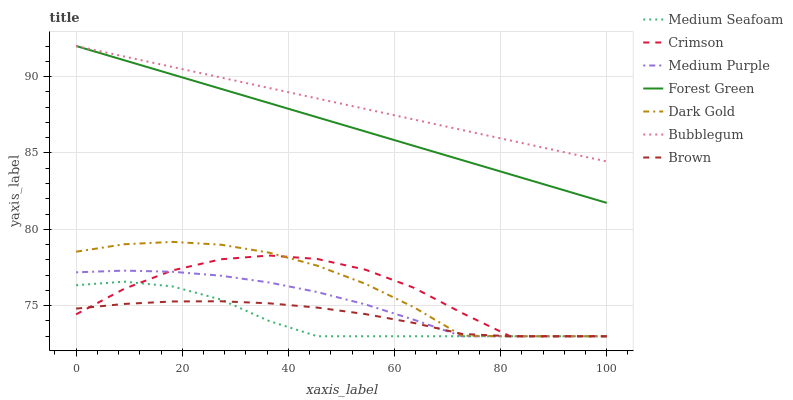Does Medium Seafoam have the minimum area under the curve?
Answer yes or no. Yes. Does Bubblegum have the maximum area under the curve?
Answer yes or no. Yes. Does Dark Gold have the minimum area under the curve?
Answer yes or no. No. Does Dark Gold have the maximum area under the curve?
Answer yes or no. No. Is Forest Green the smoothest?
Answer yes or no. Yes. Is Crimson the roughest?
Answer yes or no. Yes. Is Dark Gold the smoothest?
Answer yes or no. No. Is Dark Gold the roughest?
Answer yes or no. No. Does Brown have the lowest value?
Answer yes or no. Yes. Does Bubblegum have the lowest value?
Answer yes or no. No. Does Forest Green have the highest value?
Answer yes or no. Yes. Does Dark Gold have the highest value?
Answer yes or no. No. Is Medium Purple less than Bubblegum?
Answer yes or no. Yes. Is Forest Green greater than Crimson?
Answer yes or no. Yes. Does Brown intersect Medium Purple?
Answer yes or no. Yes. Is Brown less than Medium Purple?
Answer yes or no. No. Is Brown greater than Medium Purple?
Answer yes or no. No. Does Medium Purple intersect Bubblegum?
Answer yes or no. No. 